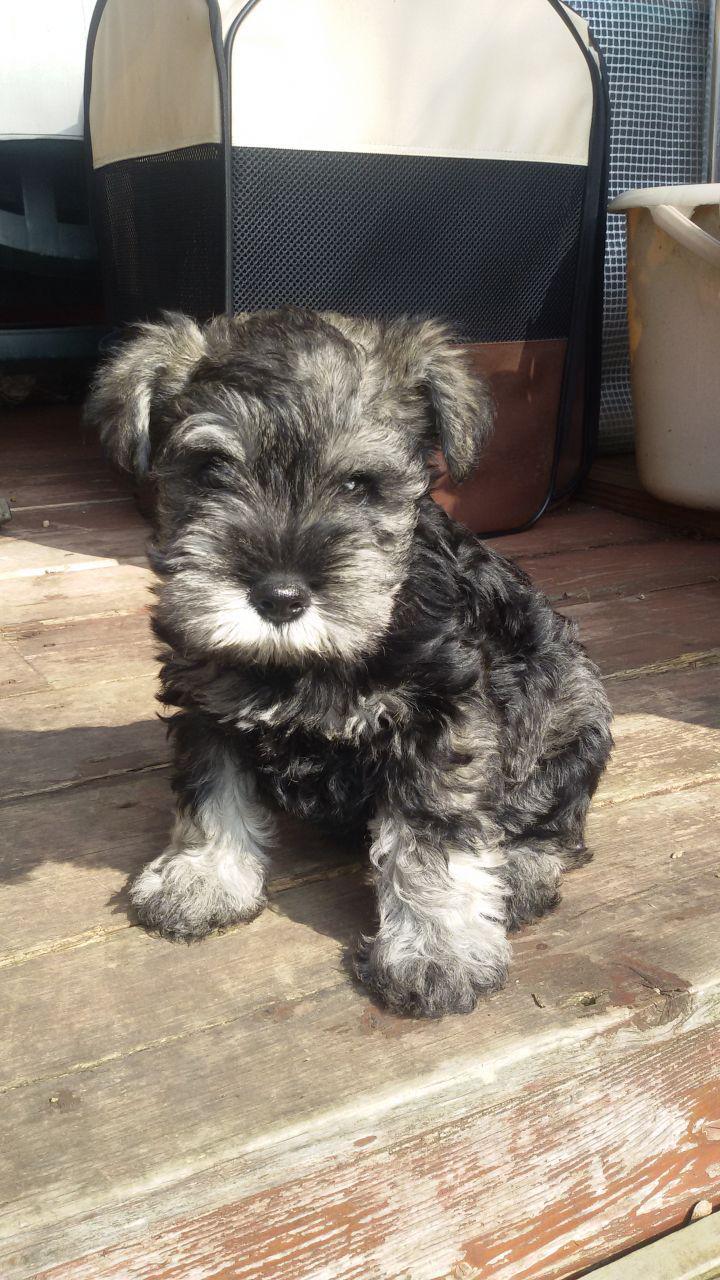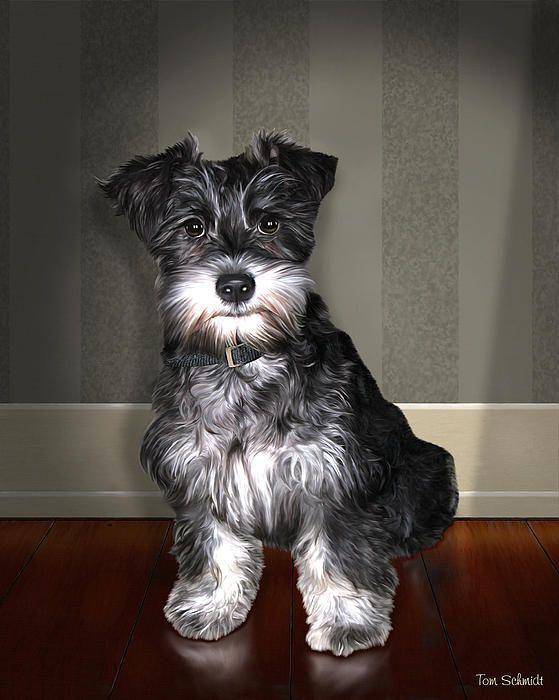The first image is the image on the left, the second image is the image on the right. Given the left and right images, does the statement "The left image shows one schnauzer with its paws propped over and its head poking out of a container, which is draped with something white." hold true? Answer yes or no. No. The first image is the image on the left, the second image is the image on the right. Assess this claim about the two images: "In one of the images there is a dog on a leash.". Correct or not? Answer yes or no. No. 